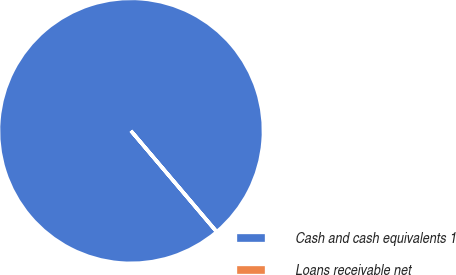<chart> <loc_0><loc_0><loc_500><loc_500><pie_chart><fcel>Cash and cash equivalents 1<fcel>Loans receivable net<nl><fcel>99.97%<fcel>0.03%<nl></chart> 